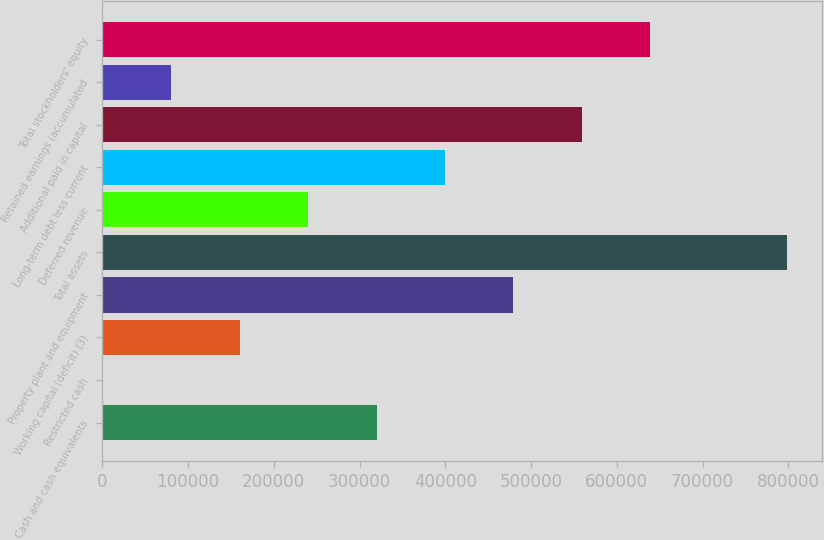Convert chart. <chart><loc_0><loc_0><loc_500><loc_500><bar_chart><fcel>Cash and cash equivalents<fcel>Restricted cash<fcel>Working capital (deficit) (3)<fcel>Property plant and equipment<fcel>Total assets<fcel>Deferred revenue<fcel>Long-term debt less current<fcel>Additional paid in capital<fcel>Retained earnings (accumulated<fcel>Total stockholders' equity<nl><fcel>319799<fcel>371<fcel>160085<fcel>479514<fcel>798942<fcel>239942<fcel>399656<fcel>559371<fcel>80228.1<fcel>639228<nl></chart> 